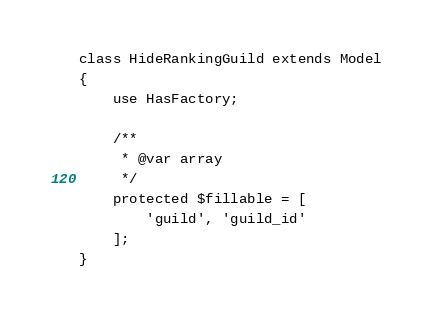<code> <loc_0><loc_0><loc_500><loc_500><_PHP_>class HideRankingGuild extends Model
{
    use HasFactory;

    /**
     * @var array
     */
    protected $fillable = [
        'guild', 'guild_id'
    ];
}
</code> 